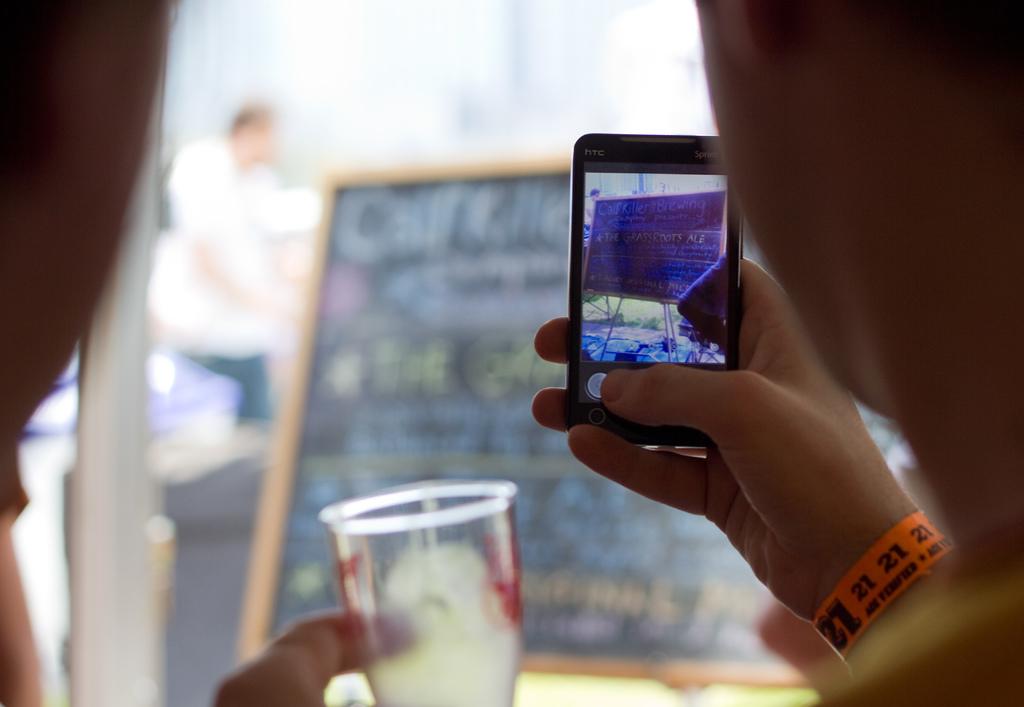What does their wrist band say?
Your answer should be compact. 21. What is the brand of the phone?
Provide a succinct answer. Htc. 